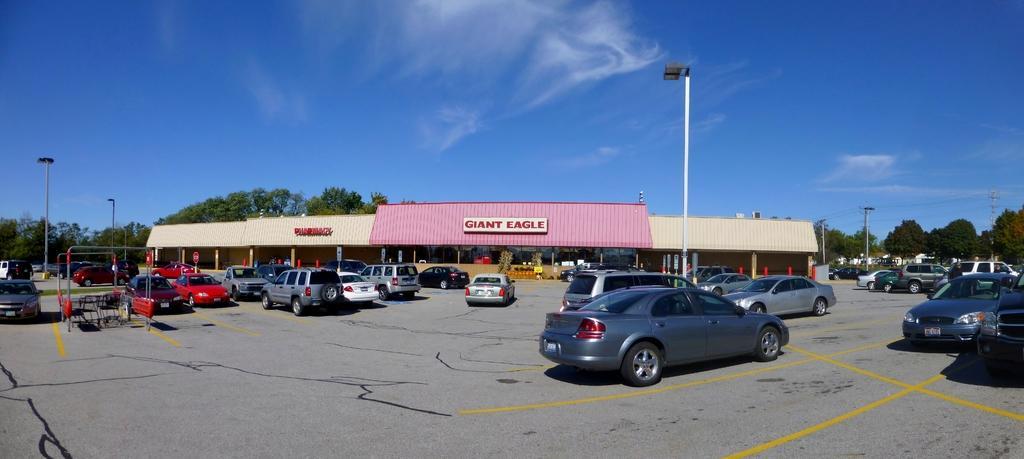Could you give a brief overview of what you see in this image? Here we can see cars, chairs, poles, trees, boards, and a shed. In the background there is sky. 